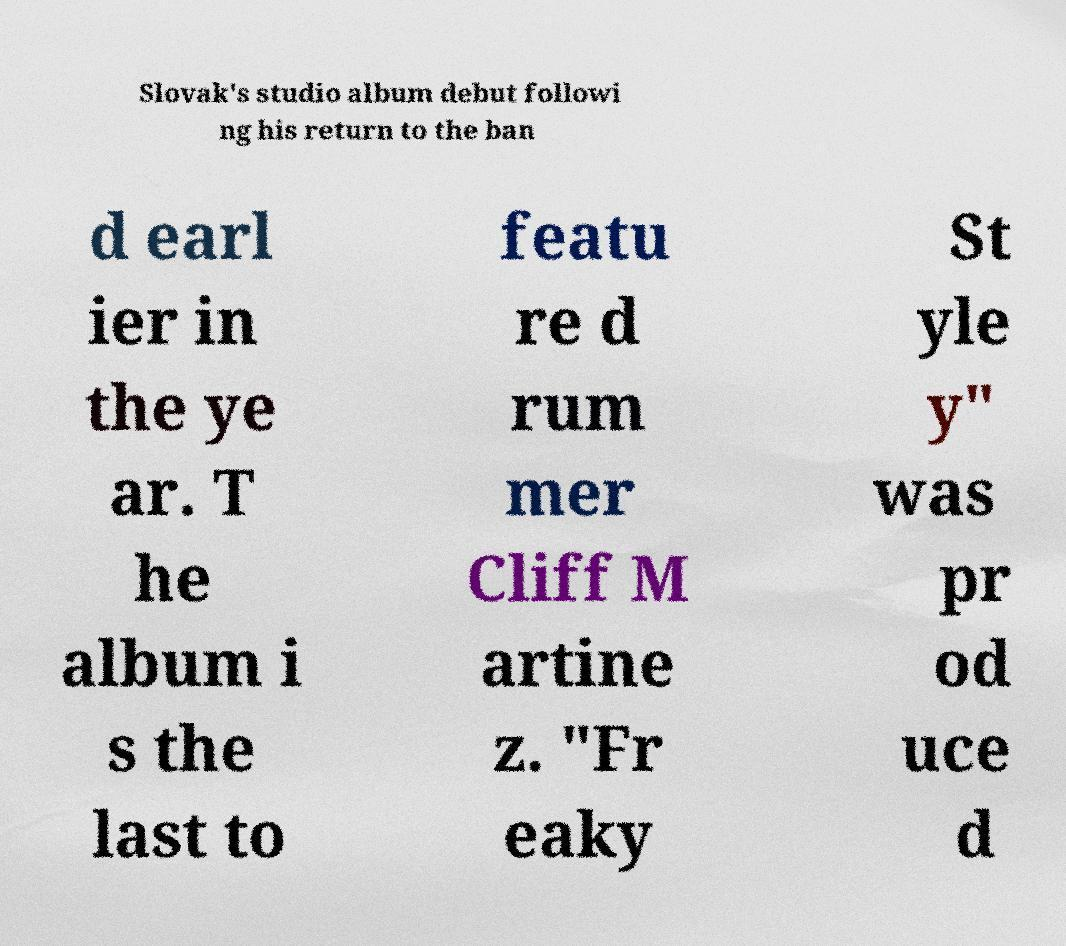For documentation purposes, I need the text within this image transcribed. Could you provide that? Slovak's studio album debut followi ng his return to the ban d earl ier in the ye ar. T he album i s the last to featu re d rum mer Cliff M artine z. "Fr eaky St yle y" was pr od uce d 